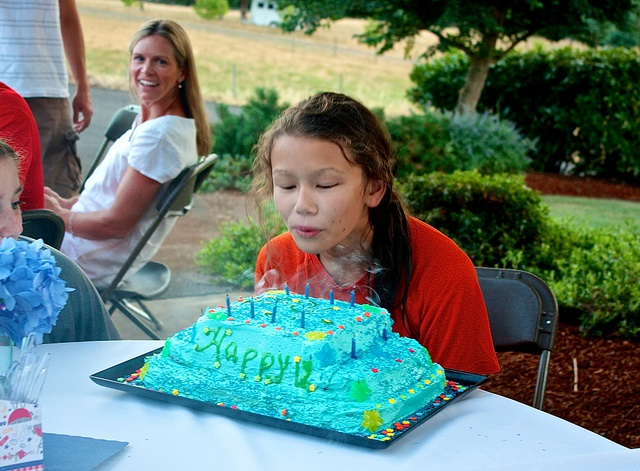Describe the objects in this image and their specific colors. I can see dining table in darkgray, lightblue, turquoise, and cyan tones, people in darkgray, black, maroon, and brown tones, cake in darkgray, turquoise, cyan, teal, and lightblue tones, people in darkgray, maroon, lightgray, and brown tones, and people in darkgray, lightblue, maroon, and black tones in this image. 